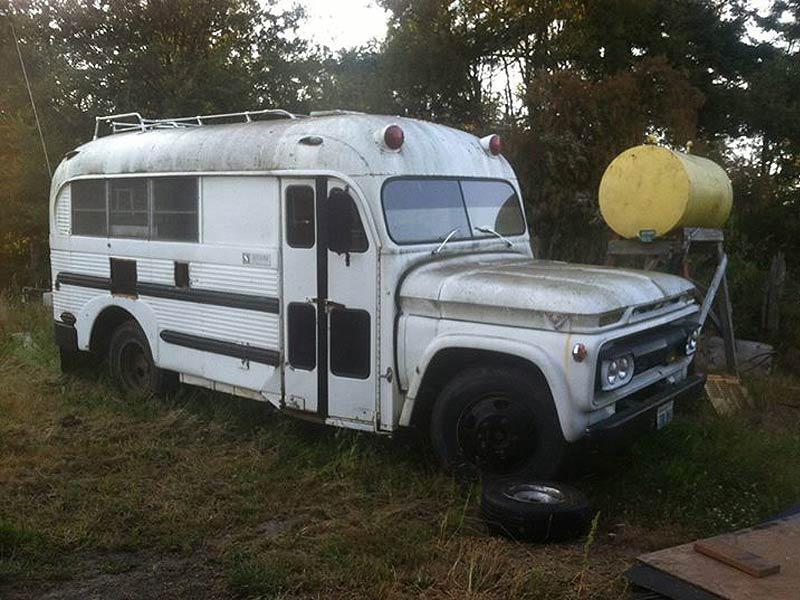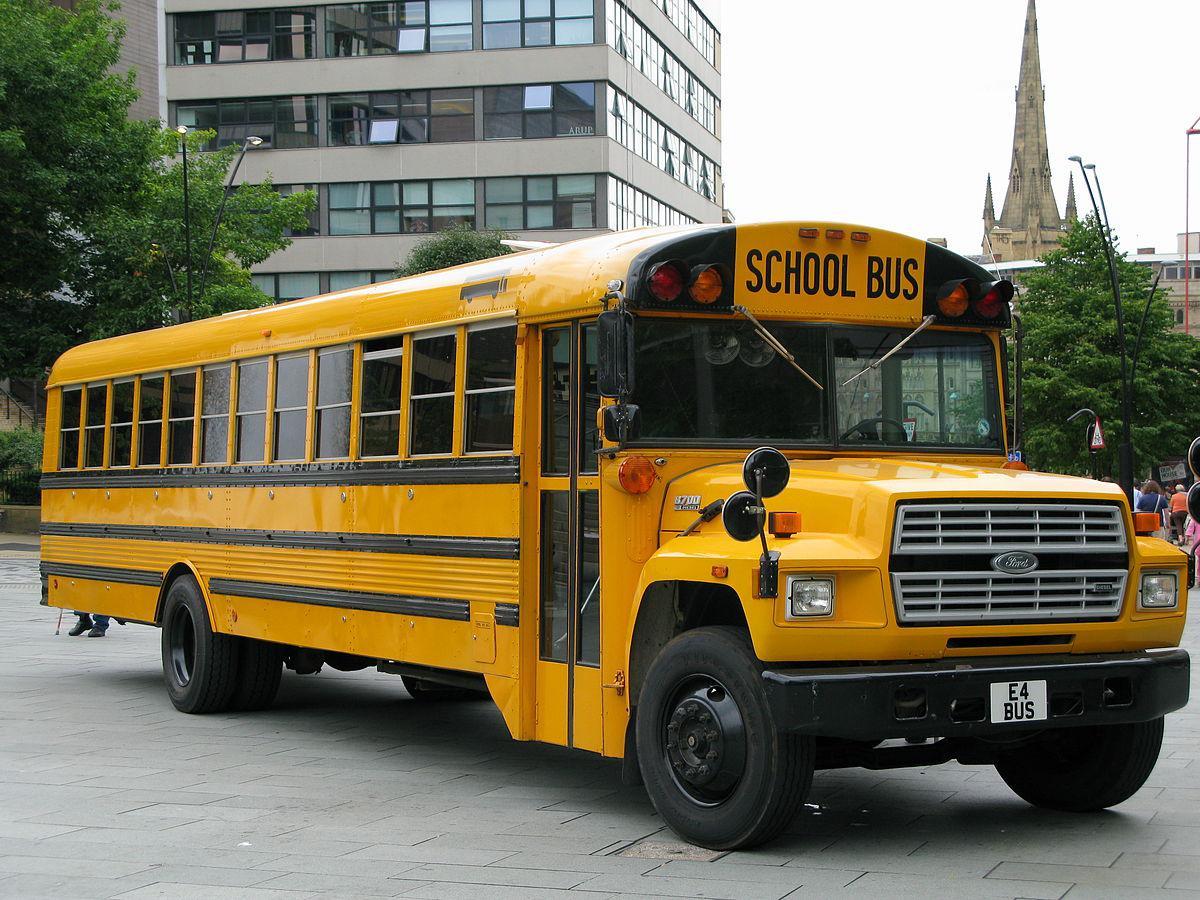The first image is the image on the left, the second image is the image on the right. For the images displayed, is the sentence "The left image shows an angled, forward-facing bus with rust and other condition issues, and the right image features a leftward-angled bus in good condition." factually correct? Answer yes or no. No. The first image is the image on the left, the second image is the image on the right. For the images displayed, is the sentence "There are at least 12 window on the rusted out bus." factually correct? Answer yes or no. No. 